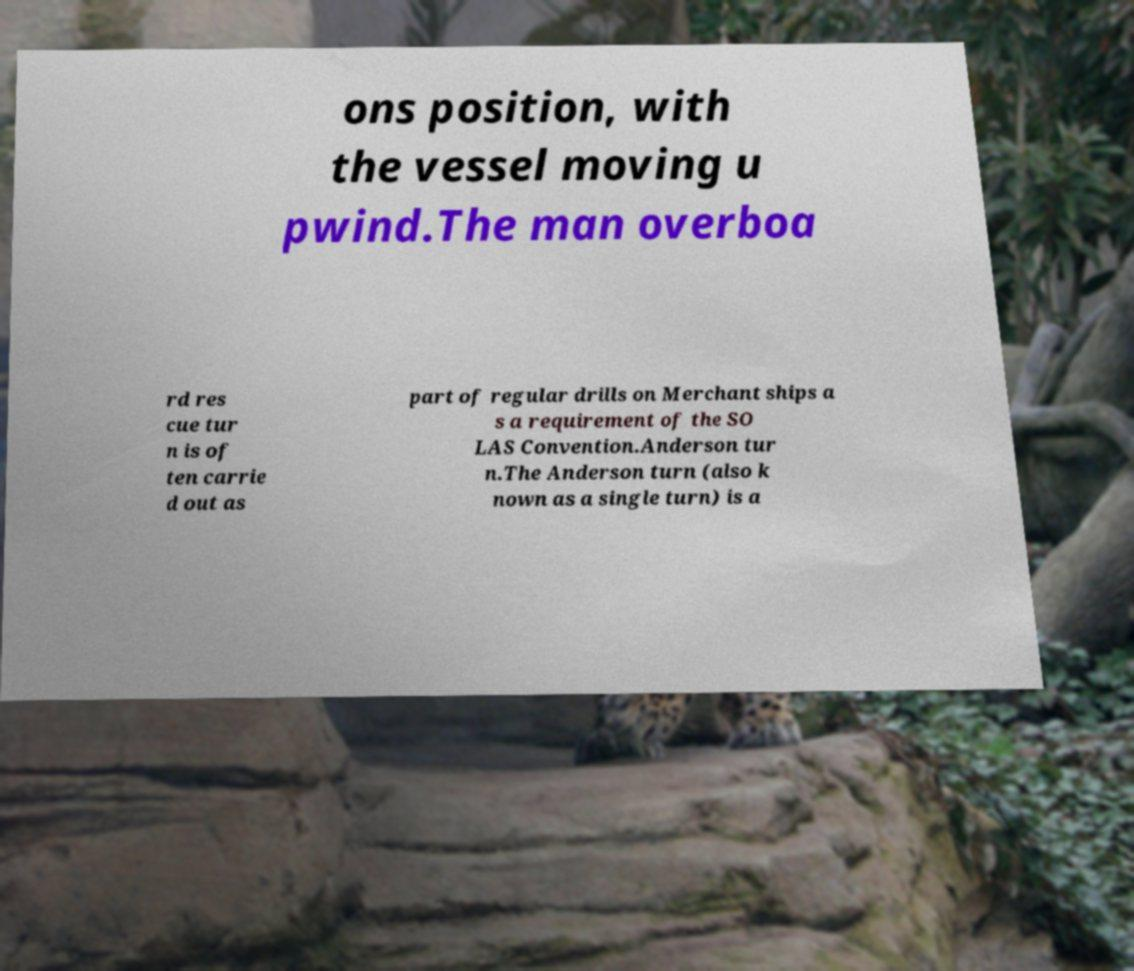There's text embedded in this image that I need extracted. Can you transcribe it verbatim? ons position, with the vessel moving u pwind.The man overboa rd res cue tur n is of ten carrie d out as part of regular drills on Merchant ships a s a requirement of the SO LAS Convention.Anderson tur n.The Anderson turn (also k nown as a single turn) is a 